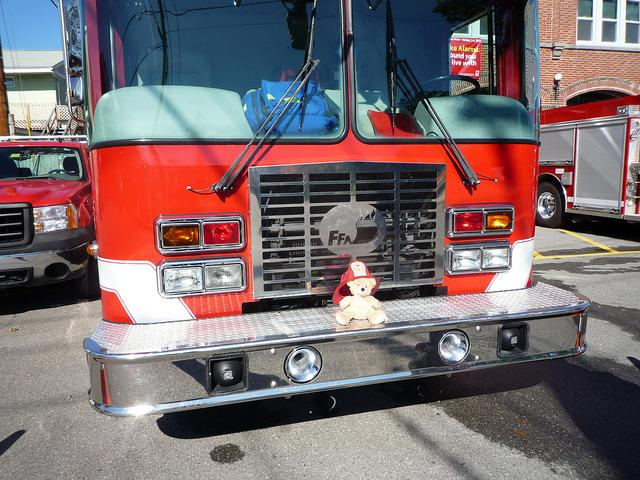How many types of fire engines are available? Please explain your reasoning. four. There are two firetrucks visible. 